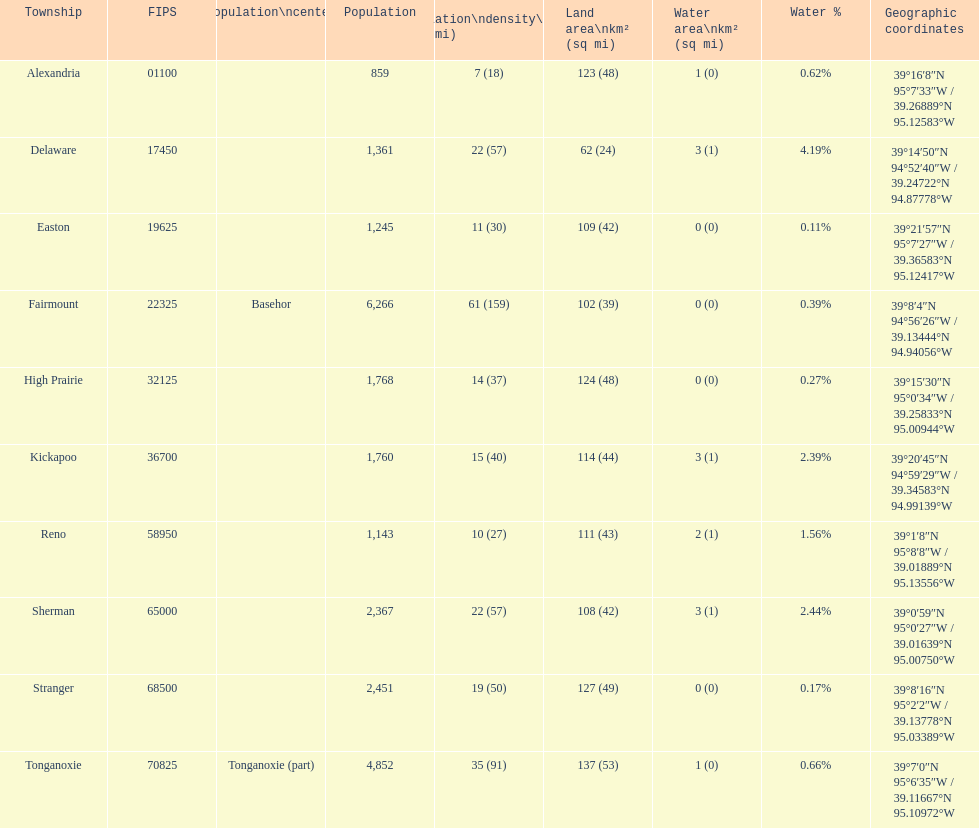In how many townships does the population surpass 2,000? 4. Would you mind parsing the complete table? {'header': ['Township', 'FIPS', 'Population\\ncenter', 'Population', 'Population\\ndensity\\n/km² (/sq\xa0mi)', 'Land area\\nkm² (sq\xa0mi)', 'Water area\\nkm² (sq\xa0mi)', 'Water\xa0%', 'Geographic coordinates'], 'rows': [['Alexandria', '01100', '', '859', '7 (18)', '123 (48)', '1 (0)', '0.62%', '39°16′8″N 95°7′33″W\ufeff / \ufeff39.26889°N 95.12583°W'], ['Delaware', '17450', '', '1,361', '22 (57)', '62 (24)', '3 (1)', '4.19%', '39°14′50″N 94°52′40″W\ufeff / \ufeff39.24722°N 94.87778°W'], ['Easton', '19625', '', '1,245', '11 (30)', '109 (42)', '0 (0)', '0.11%', '39°21′57″N 95°7′27″W\ufeff / \ufeff39.36583°N 95.12417°W'], ['Fairmount', '22325', 'Basehor', '6,266', '61 (159)', '102 (39)', '0 (0)', '0.39%', '39°8′4″N 94°56′26″W\ufeff / \ufeff39.13444°N 94.94056°W'], ['High Prairie', '32125', '', '1,768', '14 (37)', '124 (48)', '0 (0)', '0.27%', '39°15′30″N 95°0′34″W\ufeff / \ufeff39.25833°N 95.00944°W'], ['Kickapoo', '36700', '', '1,760', '15 (40)', '114 (44)', '3 (1)', '2.39%', '39°20′45″N 94°59′29″W\ufeff / \ufeff39.34583°N 94.99139°W'], ['Reno', '58950', '', '1,143', '10 (27)', '111 (43)', '2 (1)', '1.56%', '39°1′8″N 95°8′8″W\ufeff / \ufeff39.01889°N 95.13556°W'], ['Sherman', '65000', '', '2,367', '22 (57)', '108 (42)', '3 (1)', '2.44%', '39°0′59″N 95°0′27″W\ufeff / \ufeff39.01639°N 95.00750°W'], ['Stranger', '68500', '', '2,451', '19 (50)', '127 (49)', '0 (0)', '0.17%', '39°8′16″N 95°2′2″W\ufeff / \ufeff39.13778°N 95.03389°W'], ['Tonganoxie', '70825', 'Tonganoxie (part)', '4,852', '35 (91)', '137 (53)', '1 (0)', '0.66%', '39°7′0″N 95°6′35″W\ufeff / \ufeff39.11667°N 95.10972°W']]} 